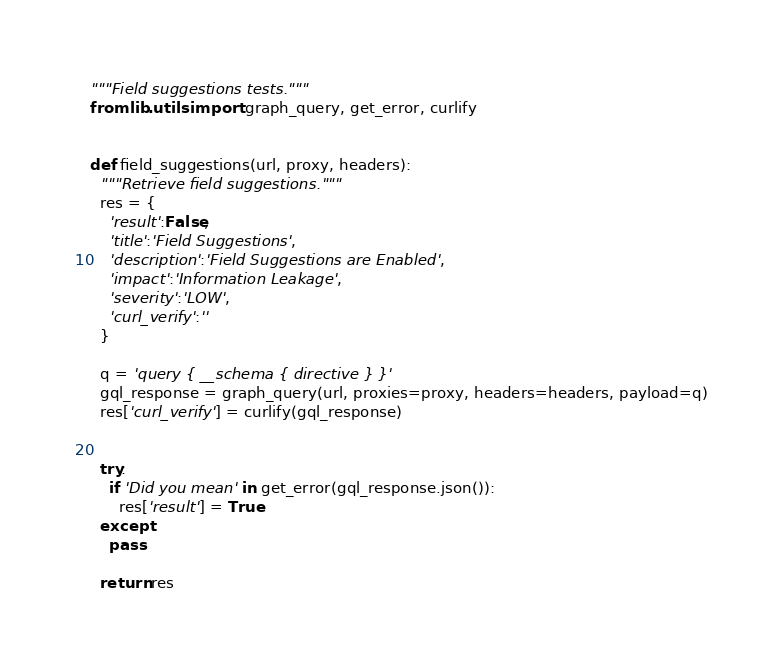<code> <loc_0><loc_0><loc_500><loc_500><_Python_>"""Field suggestions tests."""
from lib.utils import graph_query, get_error, curlify


def field_suggestions(url, proxy, headers):
  """Retrieve field suggestions."""
  res = {
    'result':False,
    'title':'Field Suggestions',
    'description':'Field Suggestions are Enabled',
    'impact':'Information Leakage',
    'severity':'LOW',
    'curl_verify':''
  }

  q = 'query { __schema { directive } }'
  gql_response = graph_query(url, proxies=proxy, headers=headers, payload=q)
  res['curl_verify'] = curlify(gql_response)
  

  try:
    if 'Did you mean' in get_error(gql_response.json()):
      res['result'] = True
  except:
    pass

  return res
</code> 